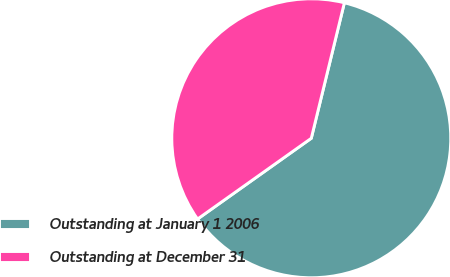Convert chart to OTSL. <chart><loc_0><loc_0><loc_500><loc_500><pie_chart><fcel>Outstanding at January 1 2006<fcel>Outstanding at December 31<nl><fcel>61.36%<fcel>38.64%<nl></chart> 